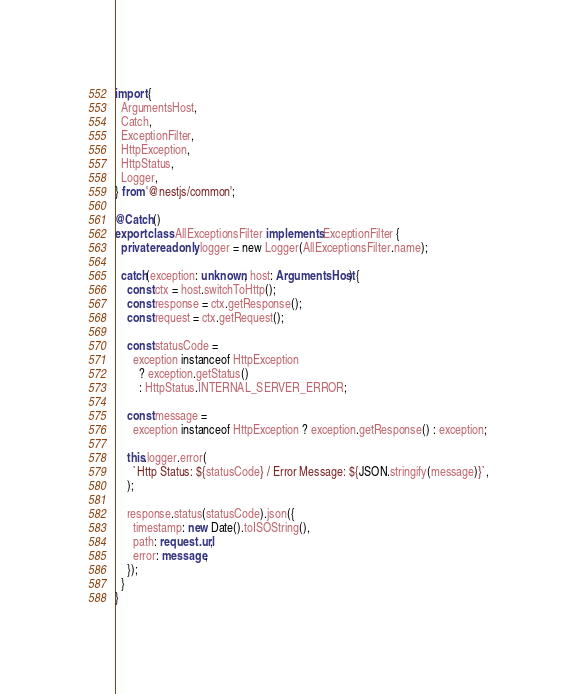Convert code to text. <code><loc_0><loc_0><loc_500><loc_500><_TypeScript_>import {
  ArgumentsHost,
  Catch,
  ExceptionFilter,
  HttpException,
  HttpStatus,
  Logger,
} from '@nestjs/common';

@Catch()
export class AllExceptionsFilter implements ExceptionFilter {
  private readonly logger = new Logger(AllExceptionsFilter.name);

  catch(exception: unknown, host: ArgumentsHost) {
    const ctx = host.switchToHttp();
    const response = ctx.getResponse();
    const request = ctx.getRequest();

    const statusCode =
      exception instanceof HttpException
        ? exception.getStatus()
        : HttpStatus.INTERNAL_SERVER_ERROR;

    const message =
      exception instanceof HttpException ? exception.getResponse() : exception;

    this.logger.error(
      `Http Status: ${statusCode} / Error Message: ${JSON.stringify(message)}`,
    );

    response.status(statusCode).json({
      timestamp: new Date().toISOString(),
      path: request.url,
      error: message,
    });
  }
}
</code> 